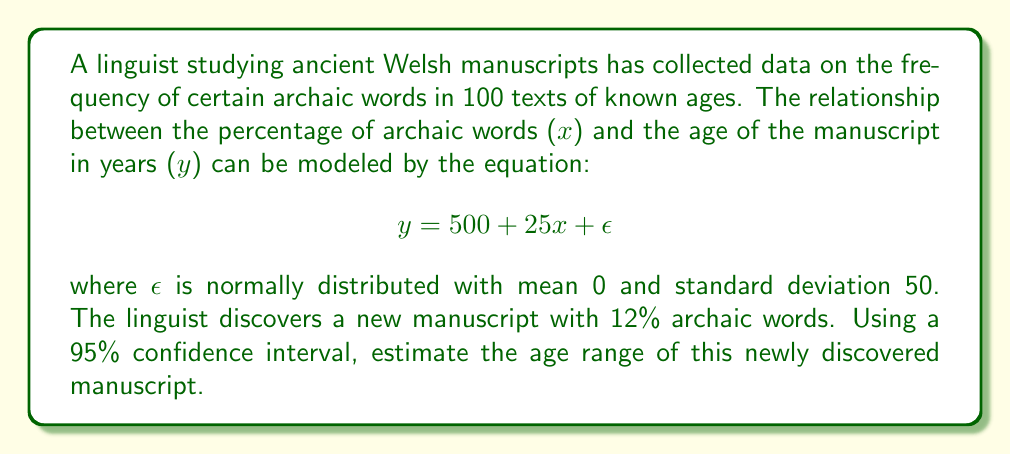Give your solution to this math problem. To solve this problem, we'll follow these steps:

1) First, we need to calculate the point estimate for the manuscript's age:
   $$ y = 500 + 25x $$
   $$ y = 500 + 25(12) = 500 + 300 = 800 $$

2) The standard error of the estimate is the given standard deviation: 50 years.

3) For a 95% confidence interval, we use a z-score of 1.96 (rounded to 2 decimal places).

4) The margin of error is calculated as:
   $$ \text{Margin of Error} = z \cdot \text{standard error} $$
   $$ \text{Margin of Error} = 1.96 \cdot 50 = 98 \text{ years} $$

5) The confidence interval is then:
   $$ \text{Point Estimate} \pm \text{Margin of Error} $$
   $$ 800 \pm 98 $$

6) Therefore, the lower bound of the interval is:
   $$ 800 - 98 = 702 \text{ years} $$

   And the upper bound is:
   $$ 800 + 98 = 898 \text{ years} $$

Thus, we can say with 95% confidence that the true age of the manuscript falls between 702 and 898 years old.
Answer: The estimated age range of the newly discovered Welsh manuscript is 702 to 898 years old, with 95% confidence. 